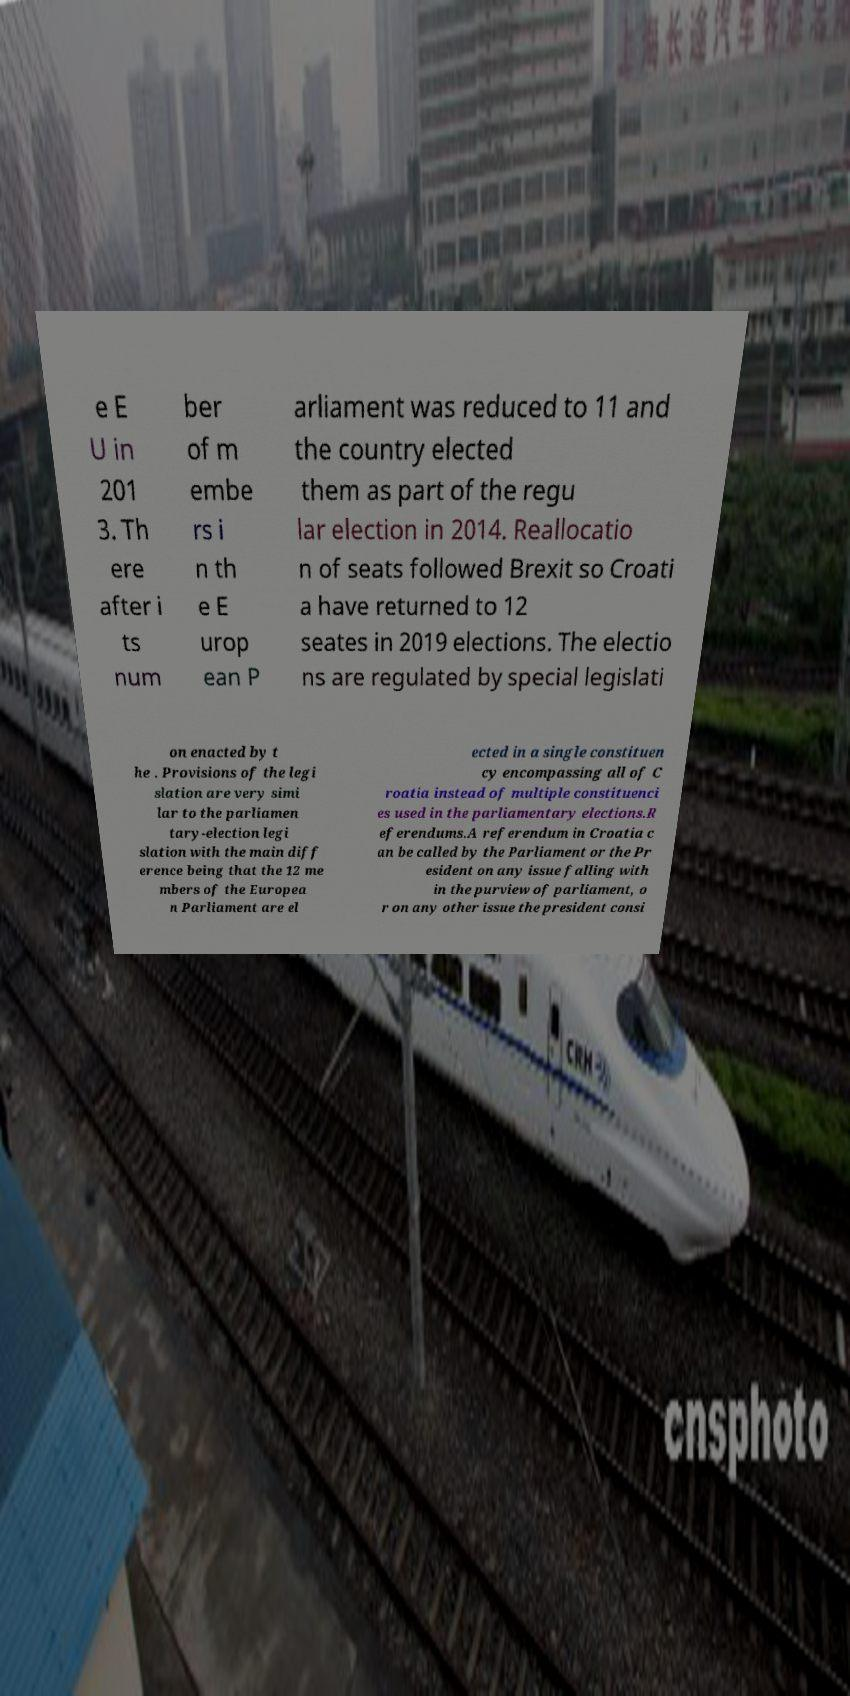What messages or text are displayed in this image? I need them in a readable, typed format. e E U in 201 3. Th ere after i ts num ber of m embe rs i n th e E urop ean P arliament was reduced to 11 and the country elected them as part of the regu lar election in 2014. Reallocatio n of seats followed Brexit so Croati a have returned to 12 seates in 2019 elections. The electio ns are regulated by special legislati on enacted by t he . Provisions of the legi slation are very simi lar to the parliamen tary-election legi slation with the main diff erence being that the 12 me mbers of the Europea n Parliament are el ected in a single constituen cy encompassing all of C roatia instead of multiple constituenci es used in the parliamentary elections.R eferendums.A referendum in Croatia c an be called by the Parliament or the Pr esident on any issue falling with in the purview of parliament, o r on any other issue the president consi 